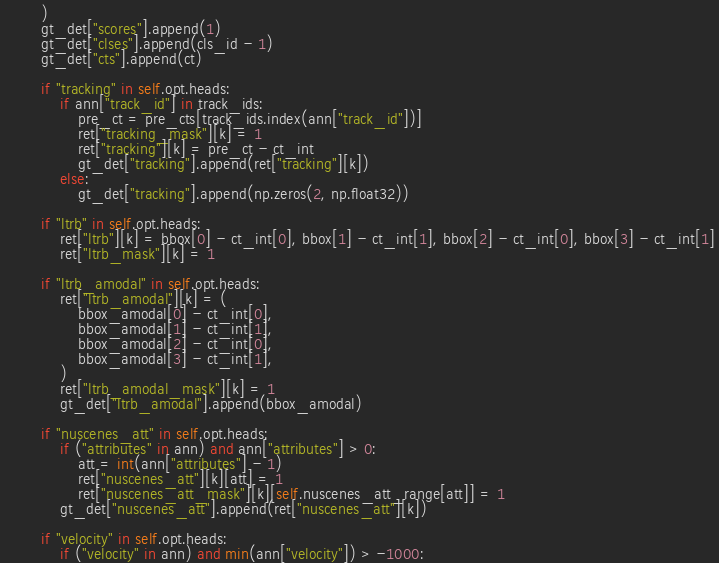Convert code to text. <code><loc_0><loc_0><loc_500><loc_500><_Python_>        )
        gt_det["scores"].append(1)
        gt_det["clses"].append(cls_id - 1)
        gt_det["cts"].append(ct)

        if "tracking" in self.opt.heads:
            if ann["track_id"] in track_ids:
                pre_ct = pre_cts[track_ids.index(ann["track_id"])]
                ret["tracking_mask"][k] = 1
                ret["tracking"][k] = pre_ct - ct_int
                gt_det["tracking"].append(ret["tracking"][k])
            else:
                gt_det["tracking"].append(np.zeros(2, np.float32))

        if "ltrb" in self.opt.heads:
            ret["ltrb"][k] = bbox[0] - ct_int[0], bbox[1] - ct_int[1], bbox[2] - ct_int[0], bbox[3] - ct_int[1]
            ret["ltrb_mask"][k] = 1

        if "ltrb_amodal" in self.opt.heads:
            ret["ltrb_amodal"][k] = (
                bbox_amodal[0] - ct_int[0],
                bbox_amodal[1] - ct_int[1],
                bbox_amodal[2] - ct_int[0],
                bbox_amodal[3] - ct_int[1],
            )
            ret["ltrb_amodal_mask"][k] = 1
            gt_det["ltrb_amodal"].append(bbox_amodal)

        if "nuscenes_att" in self.opt.heads:
            if ("attributes" in ann) and ann["attributes"] > 0:
                att = int(ann["attributes"] - 1)
                ret["nuscenes_att"][k][att] = 1
                ret["nuscenes_att_mask"][k][self.nuscenes_att_range[att]] = 1
            gt_det["nuscenes_att"].append(ret["nuscenes_att"][k])

        if "velocity" in self.opt.heads:
            if ("velocity" in ann) and min(ann["velocity"]) > -1000:</code> 